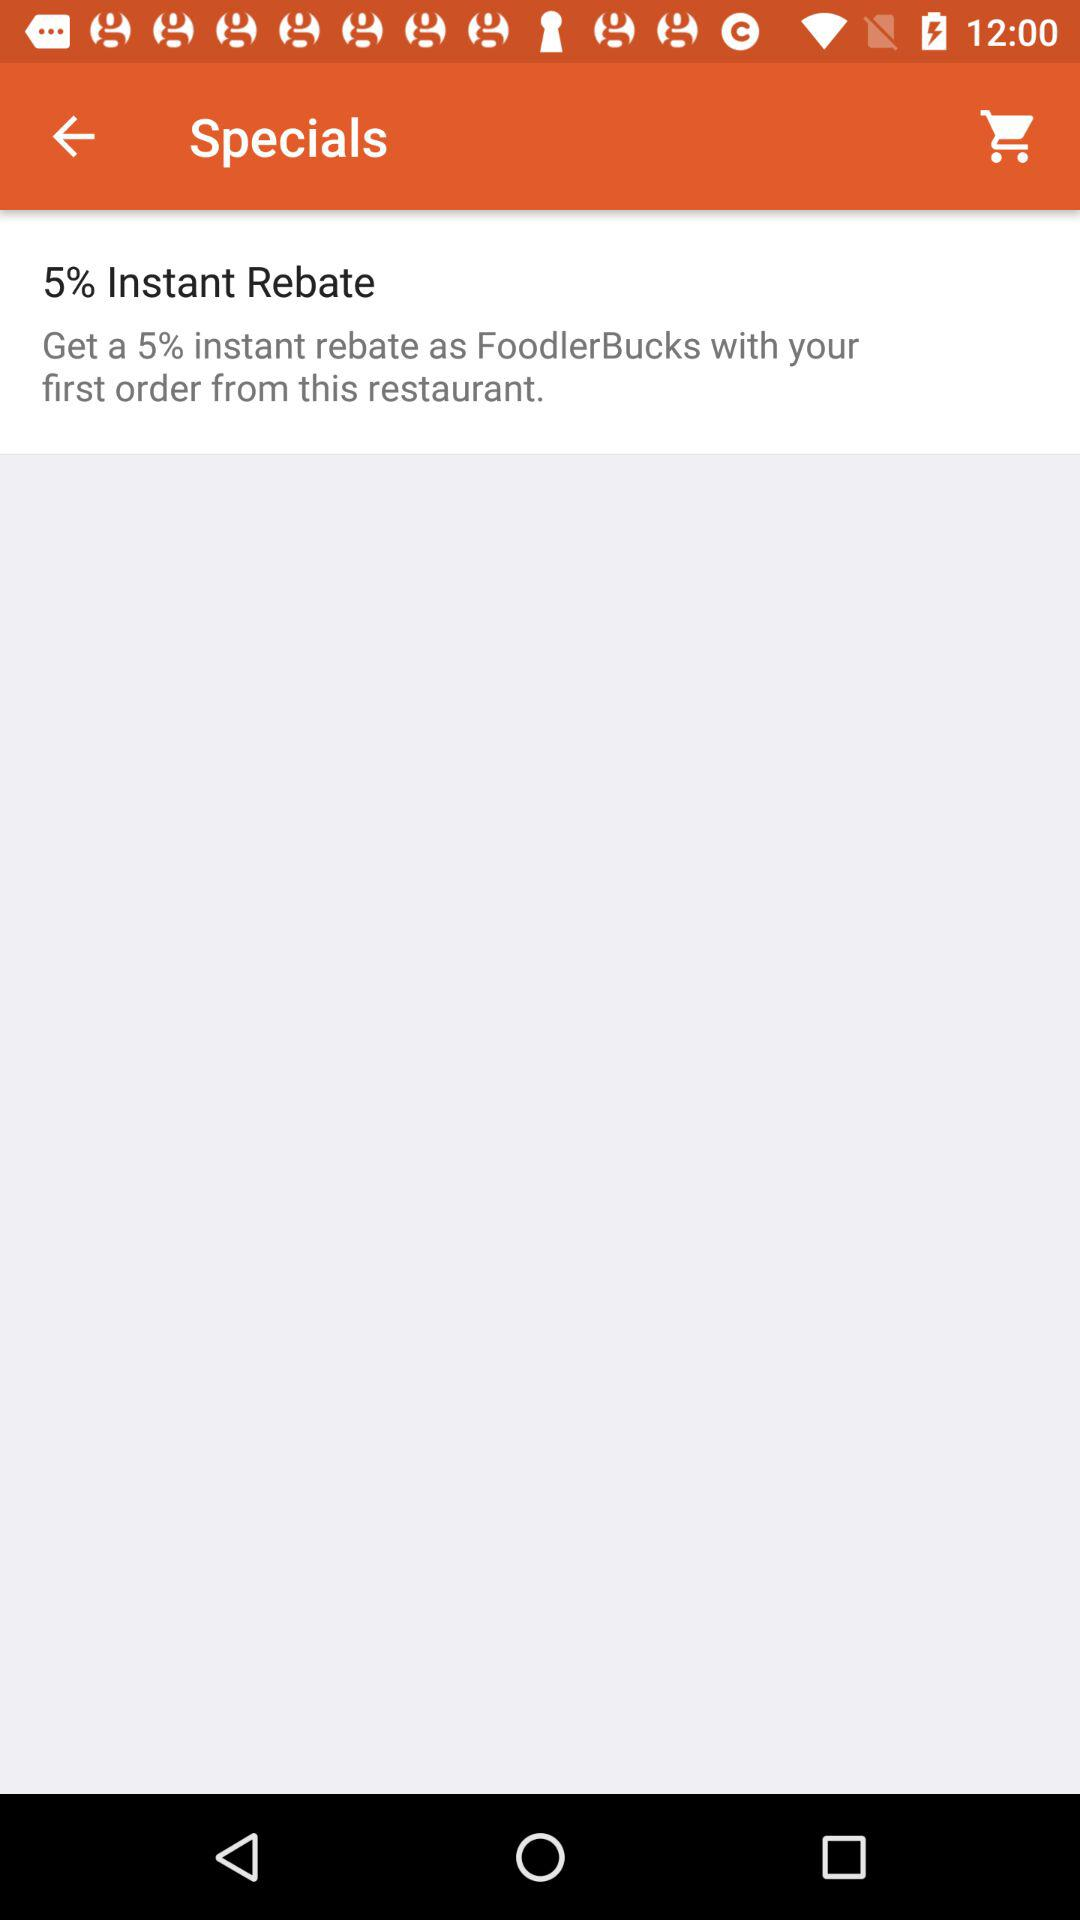How much is the total cost of the first order?
When the provided information is insufficient, respond with <no answer>. <no answer> 